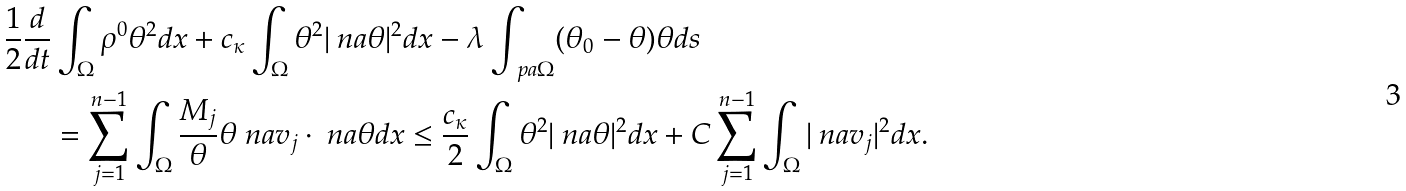Convert formula to latex. <formula><loc_0><loc_0><loc_500><loc_500>\frac { 1 } { 2 } \frac { d } { d t } & \int _ { \Omega } \rho ^ { 0 } \theta ^ { 2 } d x + c _ { \kappa } \int _ { \Omega } \theta ^ { 2 } | \ n a \theta | ^ { 2 } d x - \lambda \int _ { \ p a \Omega } ( \theta _ { 0 } - \theta ) \theta d s \\ & = \sum _ { j = 1 } ^ { n - 1 } \int _ { \Omega } \frac { M _ { j } } { \theta } \theta \ n a v _ { j } \cdot \ n a \theta d x \leq \frac { c _ { \kappa } } { 2 } \int _ { \Omega } \theta ^ { 2 } | \ n a \theta | ^ { 2 } d x + C \sum _ { j = 1 } ^ { n - 1 } \int _ { \Omega } | \ n a v _ { j } | ^ { 2 } d x .</formula> 